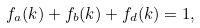Convert formula to latex. <formula><loc_0><loc_0><loc_500><loc_500>f _ { a } ( k ) + f _ { b } ( k ) + f _ { d } ( k ) = 1 ,</formula> 